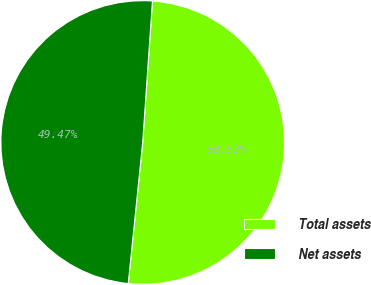<chart> <loc_0><loc_0><loc_500><loc_500><pie_chart><fcel>Total assets<fcel>Net assets<nl><fcel>50.53%<fcel>49.47%<nl></chart> 